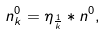<formula> <loc_0><loc_0><loc_500><loc_500>n _ { k } ^ { 0 } = \eta _ { \frac { 1 } { k } } * n ^ { 0 } ,</formula> 